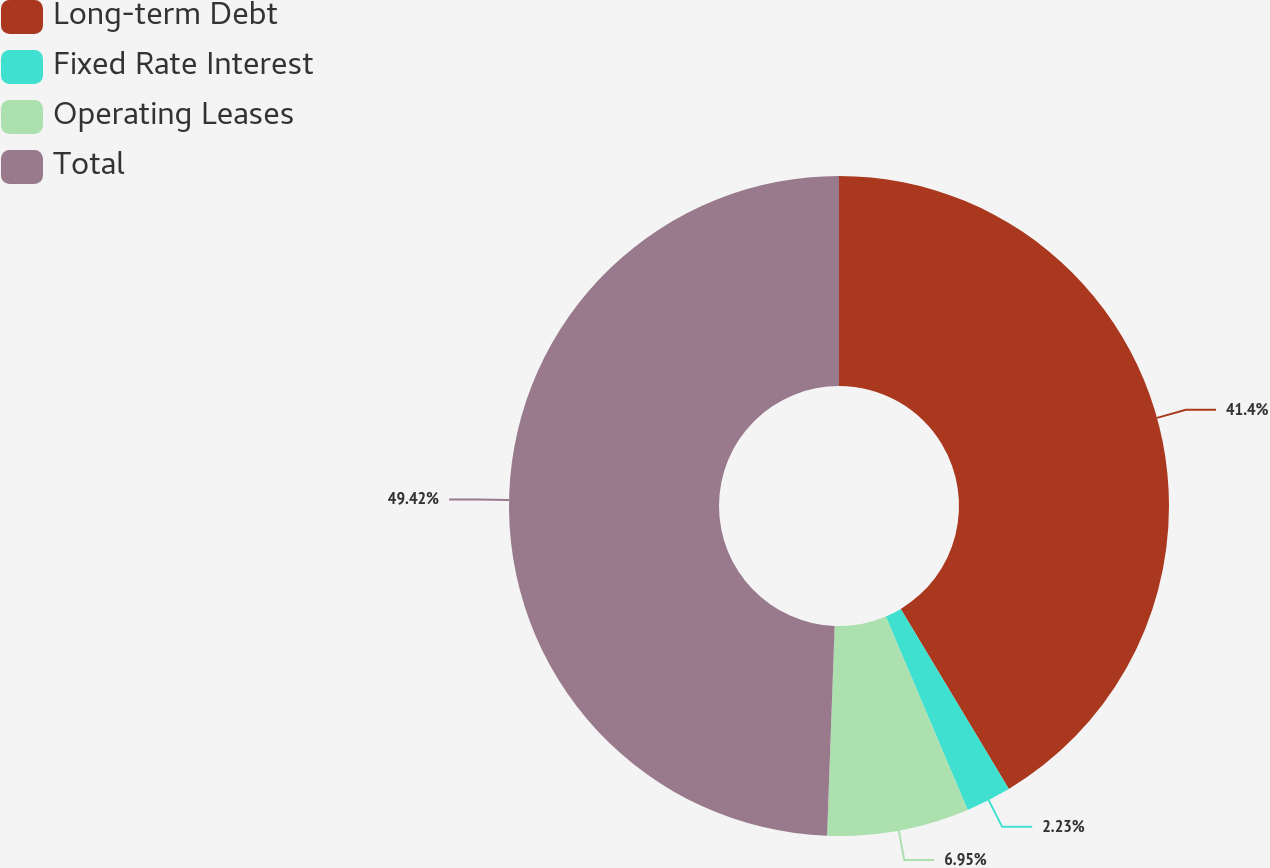<chart> <loc_0><loc_0><loc_500><loc_500><pie_chart><fcel>Long-term Debt<fcel>Fixed Rate Interest<fcel>Operating Leases<fcel>Total<nl><fcel>41.4%<fcel>2.23%<fcel>6.95%<fcel>49.43%<nl></chart> 